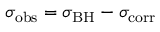<formula> <loc_0><loc_0><loc_500><loc_500>\sigma _ { o b s } = \sigma _ { B H } - \sigma _ { c o r r }</formula> 